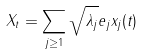Convert formula to latex. <formula><loc_0><loc_0><loc_500><loc_500>X _ { t } = \sum _ { j \geq 1 } \sqrt { \lambda _ { j } } e _ { j } x _ { j } ( t )</formula> 